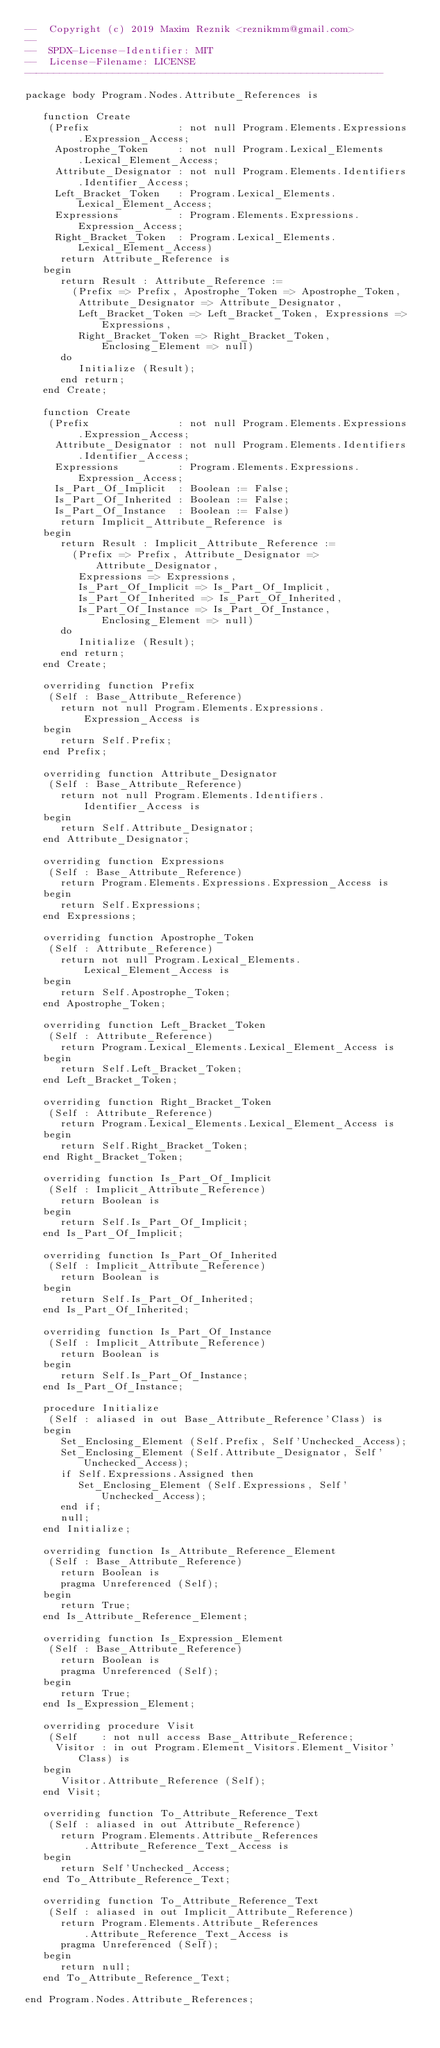Convert code to text. <code><loc_0><loc_0><loc_500><loc_500><_Ada_>--  Copyright (c) 2019 Maxim Reznik <reznikmm@gmail.com>
--
--  SPDX-License-Identifier: MIT
--  License-Filename: LICENSE
-------------------------------------------------------------

package body Program.Nodes.Attribute_References is

   function Create
    (Prefix               : not null Program.Elements.Expressions
         .Expression_Access;
     Apostrophe_Token     : not null Program.Lexical_Elements
         .Lexical_Element_Access;
     Attribute_Designator : not null Program.Elements.Identifiers
         .Identifier_Access;
     Left_Bracket_Token   : Program.Lexical_Elements.Lexical_Element_Access;
     Expressions          : Program.Elements.Expressions.Expression_Access;
     Right_Bracket_Token  : Program.Lexical_Elements.Lexical_Element_Access)
      return Attribute_Reference is
   begin
      return Result : Attribute_Reference :=
        (Prefix => Prefix, Apostrophe_Token => Apostrophe_Token,
         Attribute_Designator => Attribute_Designator,
         Left_Bracket_Token => Left_Bracket_Token, Expressions => Expressions,
         Right_Bracket_Token => Right_Bracket_Token, Enclosing_Element => null)
      do
         Initialize (Result);
      end return;
   end Create;

   function Create
    (Prefix               : not null Program.Elements.Expressions
         .Expression_Access;
     Attribute_Designator : not null Program.Elements.Identifiers
         .Identifier_Access;
     Expressions          : Program.Elements.Expressions.Expression_Access;
     Is_Part_Of_Implicit  : Boolean := False;
     Is_Part_Of_Inherited : Boolean := False;
     Is_Part_Of_Instance  : Boolean := False)
      return Implicit_Attribute_Reference is
   begin
      return Result : Implicit_Attribute_Reference :=
        (Prefix => Prefix, Attribute_Designator => Attribute_Designator,
         Expressions => Expressions,
         Is_Part_Of_Implicit => Is_Part_Of_Implicit,
         Is_Part_Of_Inherited => Is_Part_Of_Inherited,
         Is_Part_Of_Instance => Is_Part_Of_Instance, Enclosing_Element => null)
      do
         Initialize (Result);
      end return;
   end Create;

   overriding function Prefix
    (Self : Base_Attribute_Reference)
      return not null Program.Elements.Expressions.Expression_Access is
   begin
      return Self.Prefix;
   end Prefix;

   overriding function Attribute_Designator
    (Self : Base_Attribute_Reference)
      return not null Program.Elements.Identifiers.Identifier_Access is
   begin
      return Self.Attribute_Designator;
   end Attribute_Designator;

   overriding function Expressions
    (Self : Base_Attribute_Reference)
      return Program.Elements.Expressions.Expression_Access is
   begin
      return Self.Expressions;
   end Expressions;

   overriding function Apostrophe_Token
    (Self : Attribute_Reference)
      return not null Program.Lexical_Elements.Lexical_Element_Access is
   begin
      return Self.Apostrophe_Token;
   end Apostrophe_Token;

   overriding function Left_Bracket_Token
    (Self : Attribute_Reference)
      return Program.Lexical_Elements.Lexical_Element_Access is
   begin
      return Self.Left_Bracket_Token;
   end Left_Bracket_Token;

   overriding function Right_Bracket_Token
    (Self : Attribute_Reference)
      return Program.Lexical_Elements.Lexical_Element_Access is
   begin
      return Self.Right_Bracket_Token;
   end Right_Bracket_Token;

   overriding function Is_Part_Of_Implicit
    (Self : Implicit_Attribute_Reference)
      return Boolean is
   begin
      return Self.Is_Part_Of_Implicit;
   end Is_Part_Of_Implicit;

   overriding function Is_Part_Of_Inherited
    (Self : Implicit_Attribute_Reference)
      return Boolean is
   begin
      return Self.Is_Part_Of_Inherited;
   end Is_Part_Of_Inherited;

   overriding function Is_Part_Of_Instance
    (Self : Implicit_Attribute_Reference)
      return Boolean is
   begin
      return Self.Is_Part_Of_Instance;
   end Is_Part_Of_Instance;

   procedure Initialize
    (Self : aliased in out Base_Attribute_Reference'Class) is
   begin
      Set_Enclosing_Element (Self.Prefix, Self'Unchecked_Access);
      Set_Enclosing_Element (Self.Attribute_Designator, Self'Unchecked_Access);
      if Self.Expressions.Assigned then
         Set_Enclosing_Element (Self.Expressions, Self'Unchecked_Access);
      end if;
      null;
   end Initialize;

   overriding function Is_Attribute_Reference_Element
    (Self : Base_Attribute_Reference)
      return Boolean is
      pragma Unreferenced (Self);
   begin
      return True;
   end Is_Attribute_Reference_Element;

   overriding function Is_Expression_Element
    (Self : Base_Attribute_Reference)
      return Boolean is
      pragma Unreferenced (Self);
   begin
      return True;
   end Is_Expression_Element;

   overriding procedure Visit
    (Self    : not null access Base_Attribute_Reference;
     Visitor : in out Program.Element_Visitors.Element_Visitor'Class) is
   begin
      Visitor.Attribute_Reference (Self);
   end Visit;

   overriding function To_Attribute_Reference_Text
    (Self : aliased in out Attribute_Reference)
      return Program.Elements.Attribute_References
          .Attribute_Reference_Text_Access is
   begin
      return Self'Unchecked_Access;
   end To_Attribute_Reference_Text;

   overriding function To_Attribute_Reference_Text
    (Self : aliased in out Implicit_Attribute_Reference)
      return Program.Elements.Attribute_References
          .Attribute_Reference_Text_Access is
      pragma Unreferenced (Self);
   begin
      return null;
   end To_Attribute_Reference_Text;

end Program.Nodes.Attribute_References;
</code> 